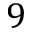Convert formula to latex. <formula><loc_0><loc_0><loc_500><loc_500>9</formula> 